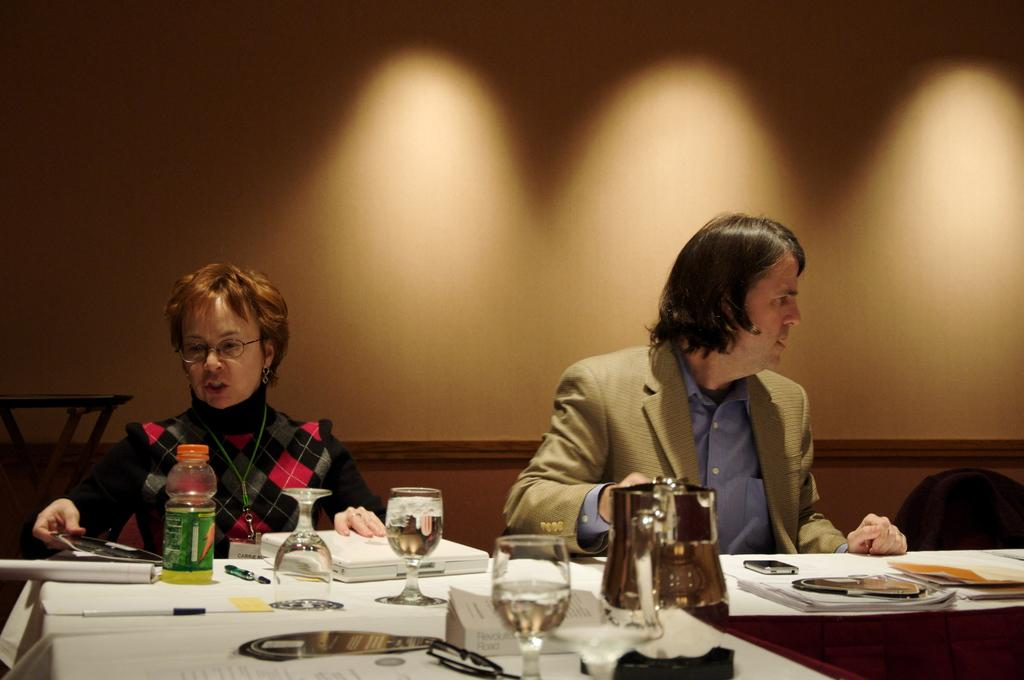Who can be seen in the image? There is a woman and a man in the image. What are the woman and the man doing in the image? Both the woman and the man are sitting on chairs. What is in front of them? There is a table in front of them. What can be found on the table? There are multiple items on the table. What can be seen in the background of the image? There is a wall visible in the background of the image. Can you describe the earthquake happening in the image? There is no earthquake depicted in the image. What type of chain can be seen connecting the two individuals in the image? There is no chain connecting the two individuals in the image; they are simply sitting on chairs with a table in front of them. 